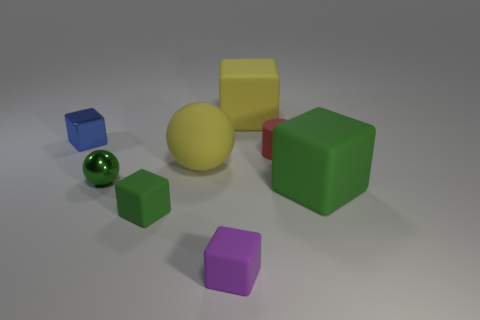Subtract all red cylinders. How many green cubes are left? 2 Subtract all tiny blue metal cubes. How many cubes are left? 4 Add 1 purple rubber objects. How many objects exist? 9 Subtract all green cubes. How many cubes are left? 3 Subtract all balls. How many objects are left? 6 Subtract all gray cubes. Subtract all gray cylinders. How many cubes are left? 5 Subtract all cyan rubber balls. Subtract all big yellow things. How many objects are left? 6 Add 7 small red rubber cylinders. How many small red rubber cylinders are left? 8 Add 8 big brown objects. How many big brown objects exist? 8 Subtract 1 green balls. How many objects are left? 7 